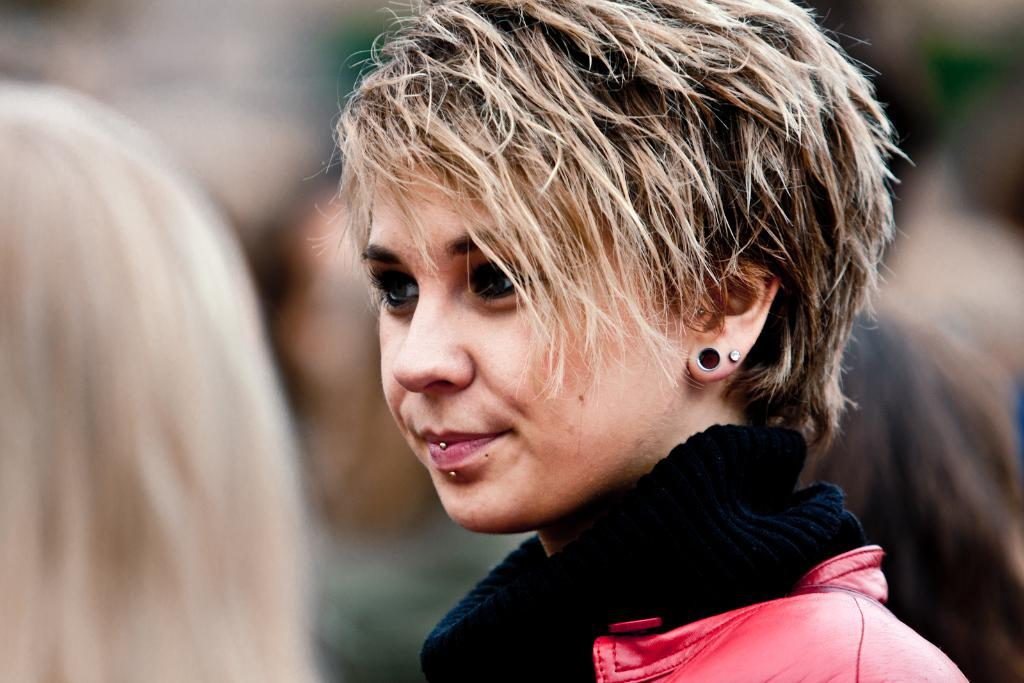Who is the main subject in the image? There is a girl in the image. What is the girl wearing? The girl is wearing a black dress and a jacket. Can you describe the background of the image? There are persons in the background of the image. What type of payment is being made in the image? There is no indication of any payment being made in the image. What advertisement can be seen in the image? There is no advertisement present in the image. 